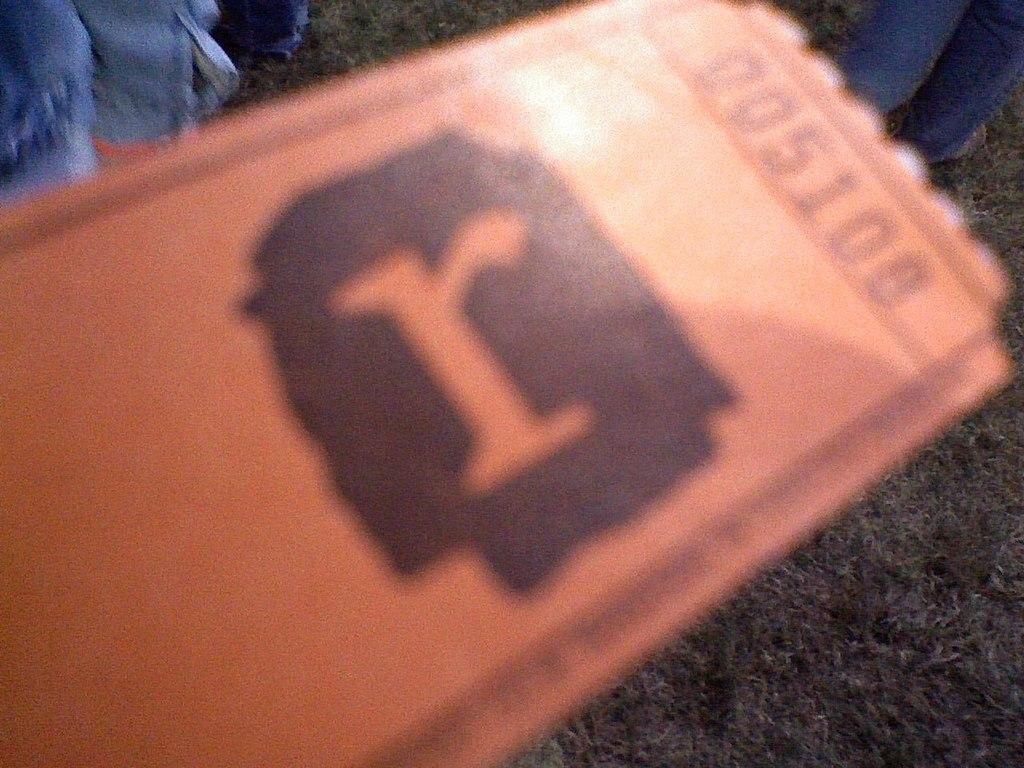Describe this image in one or two sentences. In this image it looks like a ticket and on top right hand corner someone is standing. 